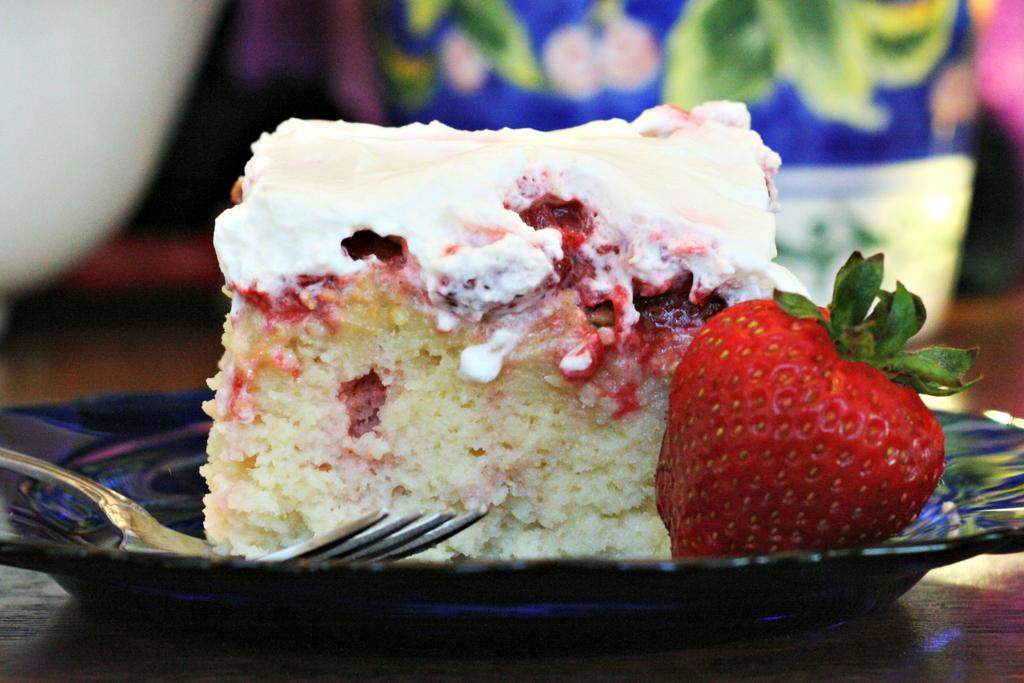What type of dessert is visible in the image? There is a piece of cake in the image. What fruit is present in the image? There are strawberries in the image. What utensil is used for eating the cake in the image? There is a fork in the image. Where is the fork placed in the image? The fork is placed on a plate in the image. What type of experience can be gained from the flag in the image? There is no flag present in the image, so no experience can be gained from it. 